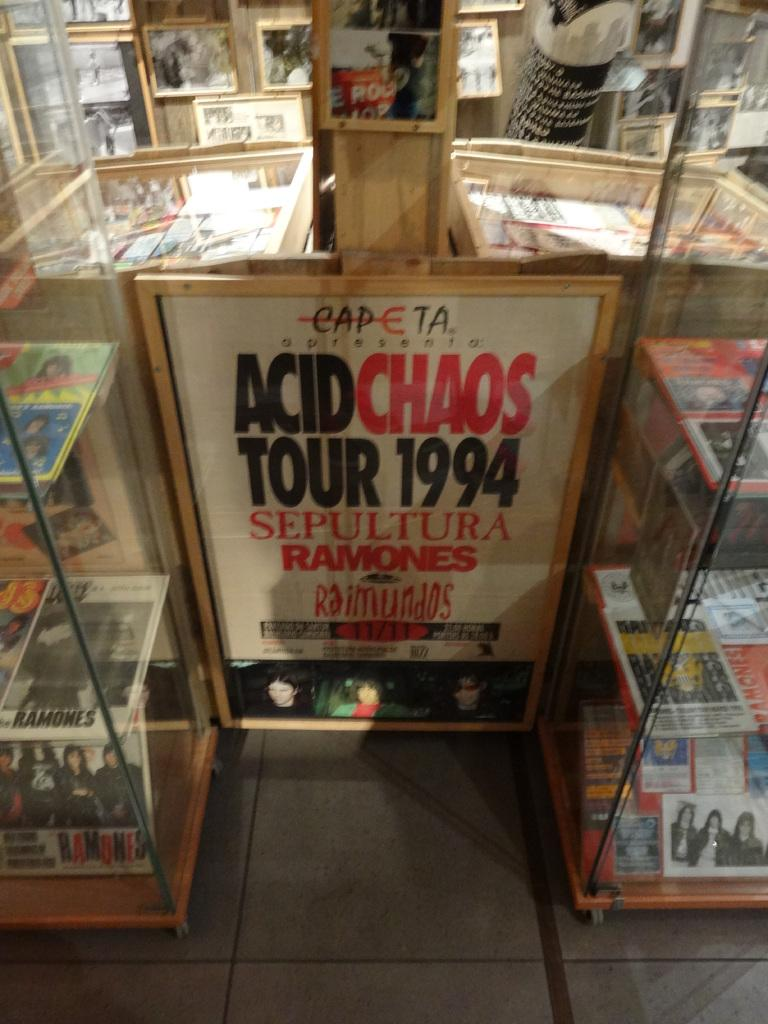<image>
Relay a brief, clear account of the picture shown. clear glass shelves surrounding a door that reads acid chaos tour 1994 